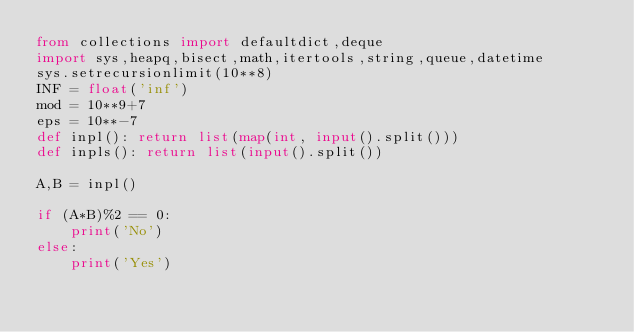Convert code to text. <code><loc_0><loc_0><loc_500><loc_500><_Python_>from collections import defaultdict,deque
import sys,heapq,bisect,math,itertools,string,queue,datetime
sys.setrecursionlimit(10**8)
INF = float('inf')
mod = 10**9+7
eps = 10**-7
def inpl(): return list(map(int, input().split()))
def inpls(): return list(input().split())

A,B = inpl()

if (A*B)%2 == 0:
	print('No')
else:
	print('Yes')
</code> 